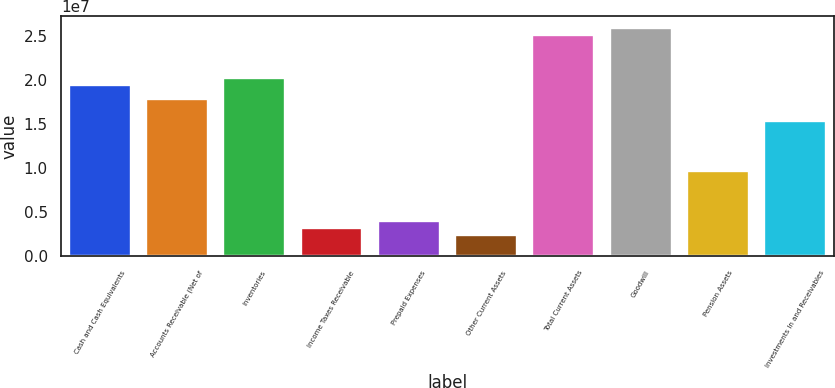<chart> <loc_0><loc_0><loc_500><loc_500><bar_chart><fcel>Cash and Cash Equivalents<fcel>Accounts Receivable (Net of<fcel>Inventories<fcel>Income Taxes Receivable<fcel>Prepaid Expenses<fcel>Other Current Assets<fcel>Total Current Assets<fcel>Goodwill<fcel>Pension Assets<fcel>Investments In and Receivables<nl><fcel>1.94559e+07<fcel>1.78349e+07<fcel>2.02664e+07<fcel>3.24605e+06<fcel>4.05654e+06<fcel>2.43556e+06<fcel>2.51294e+07<fcel>2.59398e+07<fcel>9.72999e+06<fcel>1.54034e+07<nl></chart> 